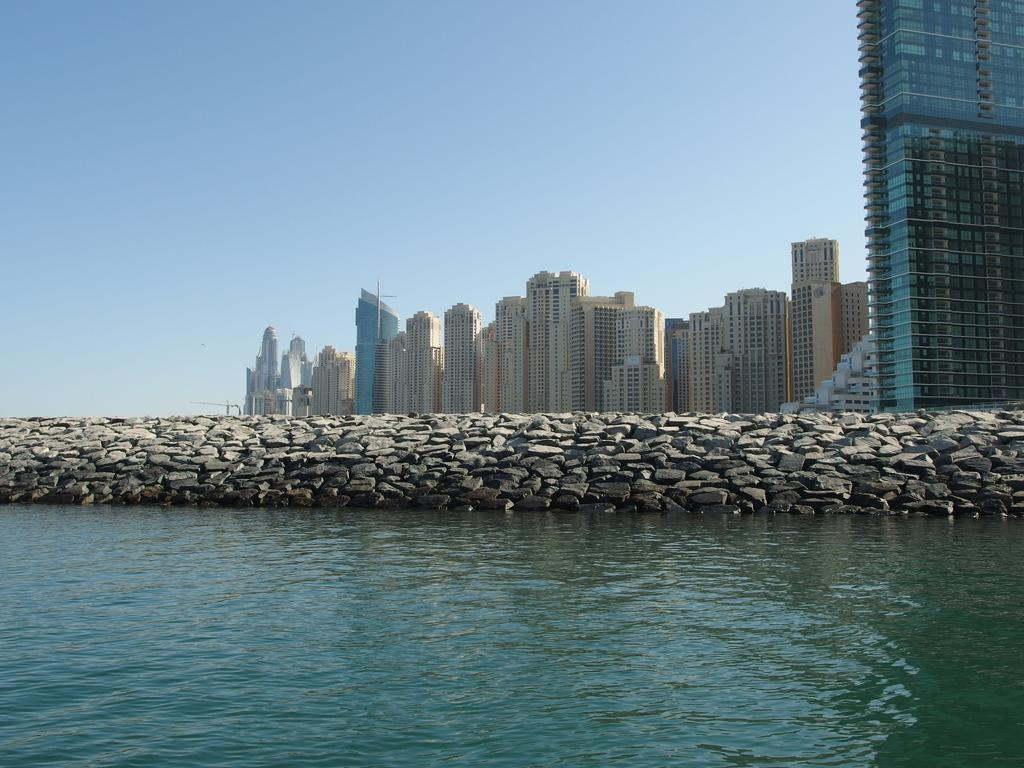What type of natural feature can be seen in the image? There is a lake in the image. What geological feature is present in the image? There is a rock wall in the image. What structures can be seen on the other side of the rock wall? There are buildings visible on the other side of the rock wall. What type of grape is growing on the rock wall in the image? There are no grapes present in the image; the rock wall is a geological feature. 